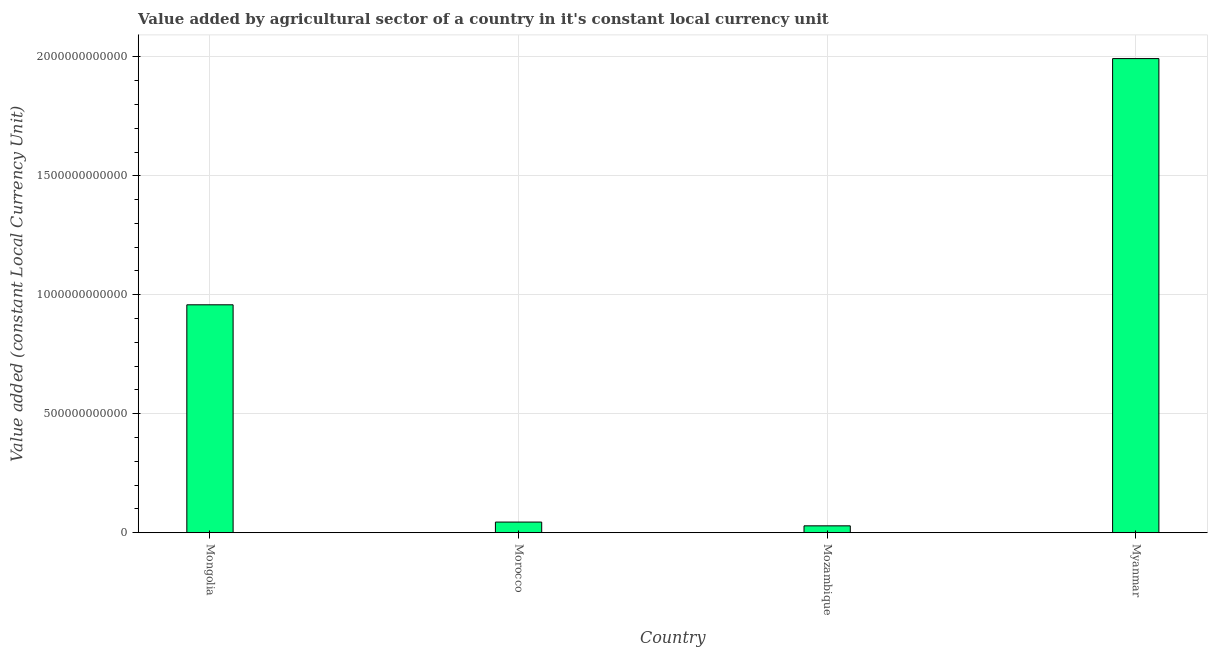What is the title of the graph?
Provide a short and direct response. Value added by agricultural sector of a country in it's constant local currency unit. What is the label or title of the X-axis?
Your answer should be compact. Country. What is the label or title of the Y-axis?
Your answer should be compact. Value added (constant Local Currency Unit). What is the value added by agriculture sector in Mozambique?
Give a very brief answer. 2.89e+1. Across all countries, what is the maximum value added by agriculture sector?
Ensure brevity in your answer.  1.99e+12. Across all countries, what is the minimum value added by agriculture sector?
Provide a short and direct response. 2.89e+1. In which country was the value added by agriculture sector maximum?
Ensure brevity in your answer.  Myanmar. In which country was the value added by agriculture sector minimum?
Offer a very short reply. Mozambique. What is the sum of the value added by agriculture sector?
Your answer should be very brief. 3.02e+12. What is the difference between the value added by agriculture sector in Morocco and Mozambique?
Your response must be concise. 1.58e+1. What is the average value added by agriculture sector per country?
Your answer should be compact. 7.56e+11. What is the median value added by agriculture sector?
Offer a terse response. 5.01e+11. In how many countries, is the value added by agriculture sector greater than 900000000000 LCU?
Keep it short and to the point. 2. What is the ratio of the value added by agriculture sector in Mongolia to that in Mozambique?
Make the answer very short. 33.12. Is the value added by agriculture sector in Mozambique less than that in Myanmar?
Your answer should be very brief. Yes. What is the difference between the highest and the second highest value added by agriculture sector?
Your answer should be compact. 1.03e+12. What is the difference between the highest and the lowest value added by agriculture sector?
Offer a terse response. 1.96e+12. In how many countries, is the value added by agriculture sector greater than the average value added by agriculture sector taken over all countries?
Offer a terse response. 2. How many bars are there?
Keep it short and to the point. 4. How many countries are there in the graph?
Provide a succinct answer. 4. What is the difference between two consecutive major ticks on the Y-axis?
Keep it short and to the point. 5.00e+11. Are the values on the major ticks of Y-axis written in scientific E-notation?
Your answer should be very brief. No. What is the Value added (constant Local Currency Unit) in Mongolia?
Provide a succinct answer. 9.58e+11. What is the Value added (constant Local Currency Unit) of Morocco?
Offer a terse response. 4.47e+1. What is the Value added (constant Local Currency Unit) of Mozambique?
Provide a succinct answer. 2.89e+1. What is the Value added (constant Local Currency Unit) in Myanmar?
Your answer should be very brief. 1.99e+12. What is the difference between the Value added (constant Local Currency Unit) in Mongolia and Morocco?
Give a very brief answer. 9.13e+11. What is the difference between the Value added (constant Local Currency Unit) in Mongolia and Mozambique?
Your answer should be compact. 9.29e+11. What is the difference between the Value added (constant Local Currency Unit) in Mongolia and Myanmar?
Your answer should be very brief. -1.03e+12. What is the difference between the Value added (constant Local Currency Unit) in Morocco and Mozambique?
Ensure brevity in your answer.  1.58e+1. What is the difference between the Value added (constant Local Currency Unit) in Morocco and Myanmar?
Your answer should be compact. -1.95e+12. What is the difference between the Value added (constant Local Currency Unit) in Mozambique and Myanmar?
Offer a very short reply. -1.96e+12. What is the ratio of the Value added (constant Local Currency Unit) in Mongolia to that in Morocco?
Offer a very short reply. 21.41. What is the ratio of the Value added (constant Local Currency Unit) in Mongolia to that in Mozambique?
Your answer should be compact. 33.12. What is the ratio of the Value added (constant Local Currency Unit) in Mongolia to that in Myanmar?
Keep it short and to the point. 0.48. What is the ratio of the Value added (constant Local Currency Unit) in Morocco to that in Mozambique?
Provide a succinct answer. 1.55. What is the ratio of the Value added (constant Local Currency Unit) in Morocco to that in Myanmar?
Offer a terse response. 0.02. What is the ratio of the Value added (constant Local Currency Unit) in Mozambique to that in Myanmar?
Ensure brevity in your answer.  0.01. 